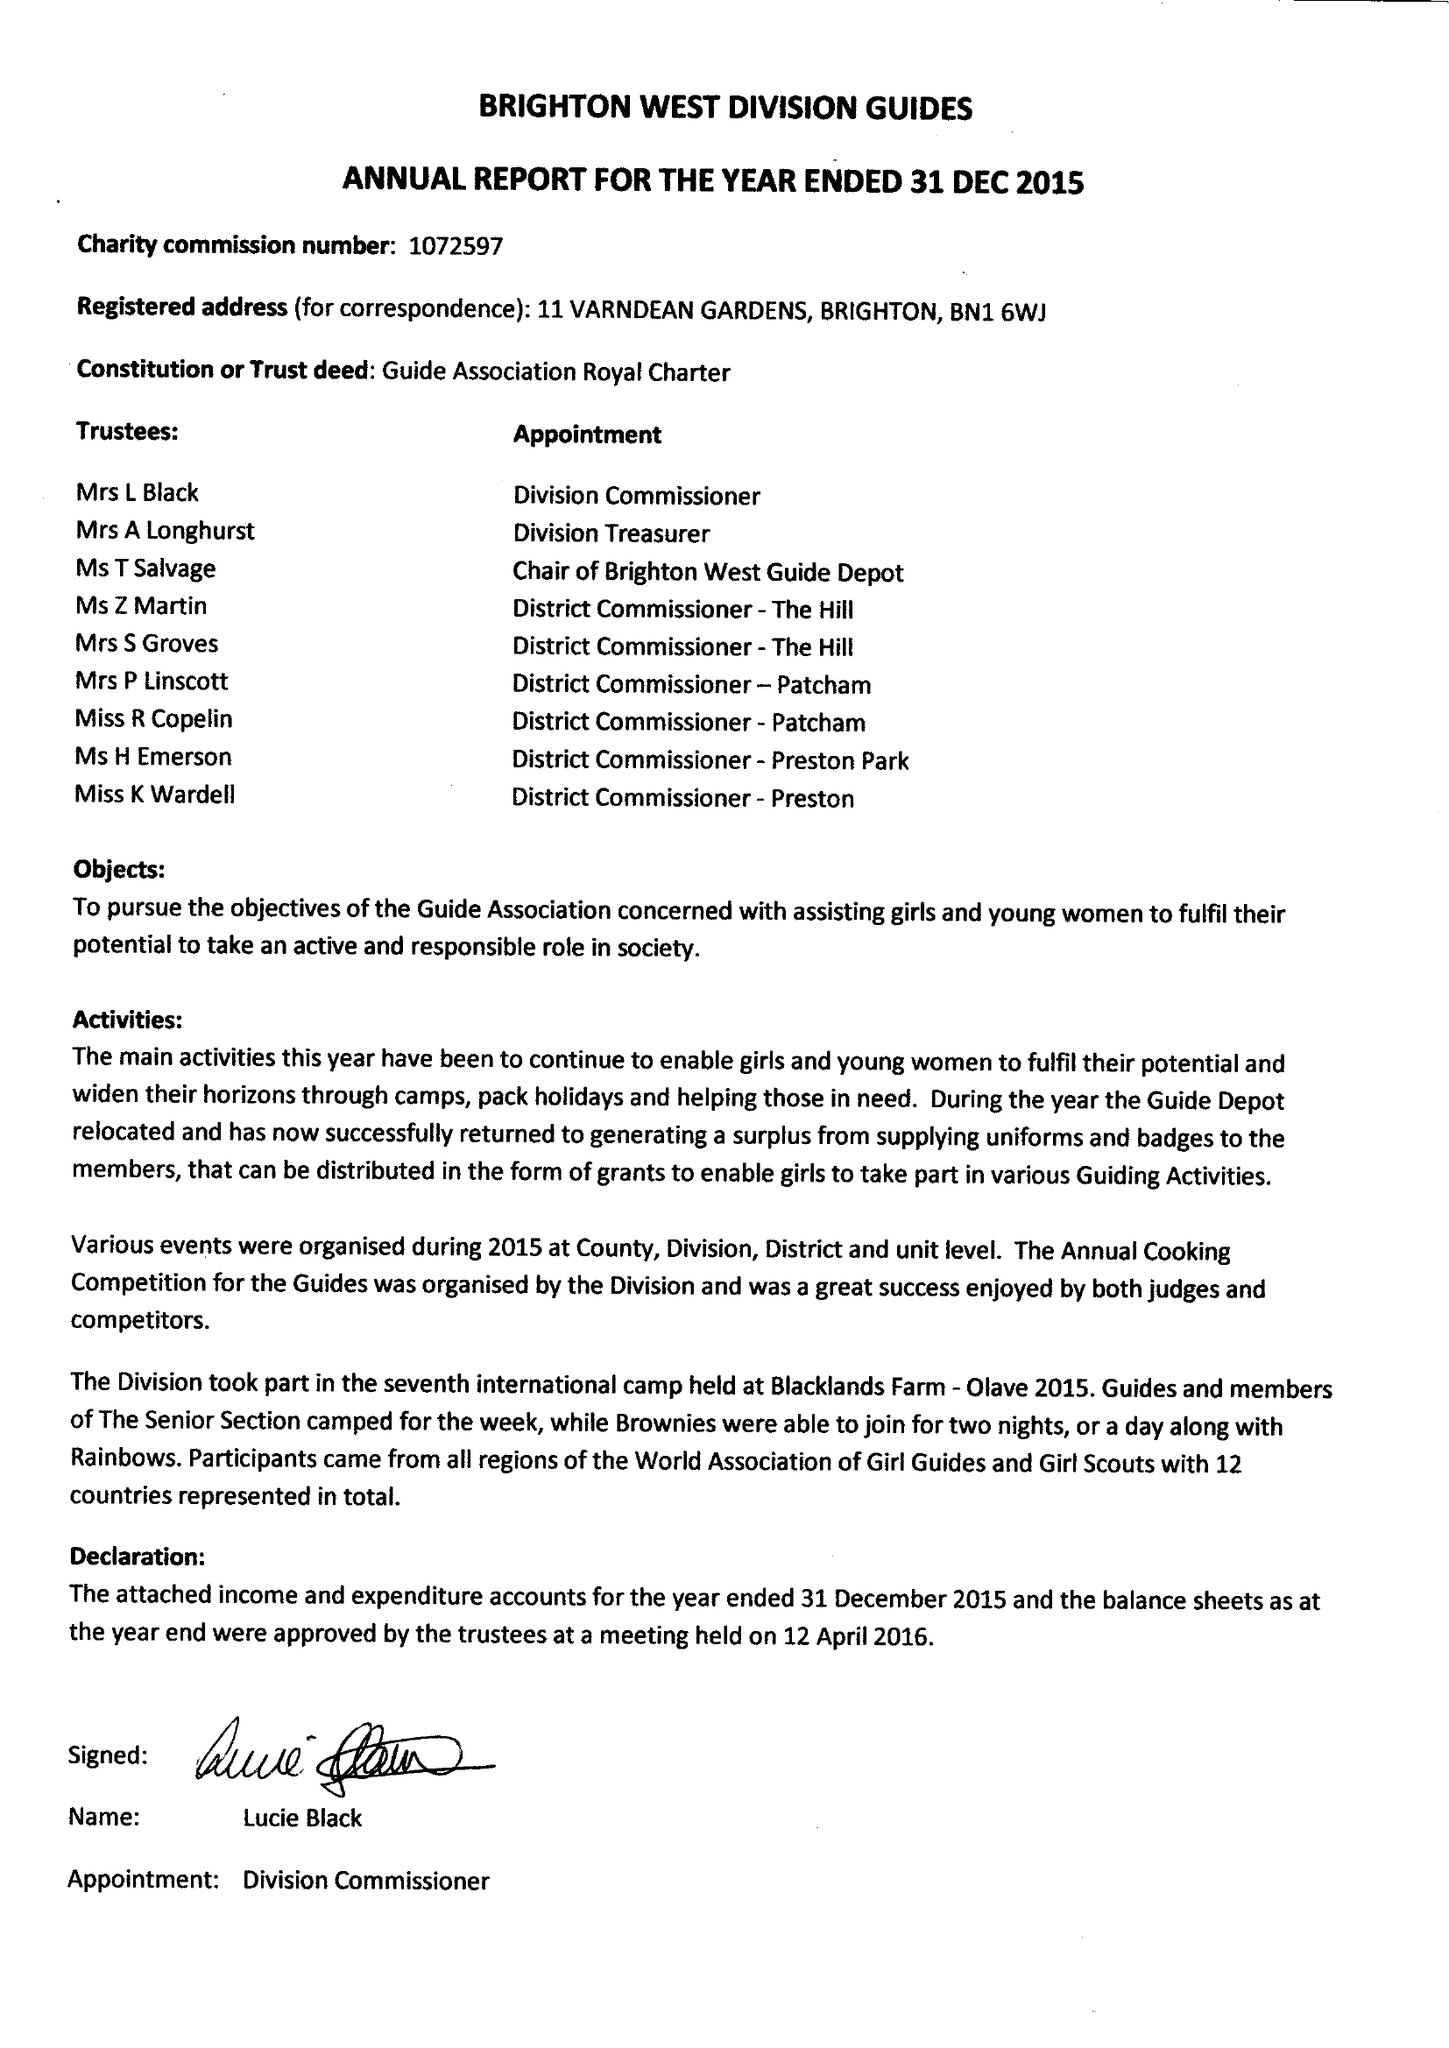What is the value for the address__street_line?
Answer the question using a single word or phrase. 11 VARNDEAN GARDENS 